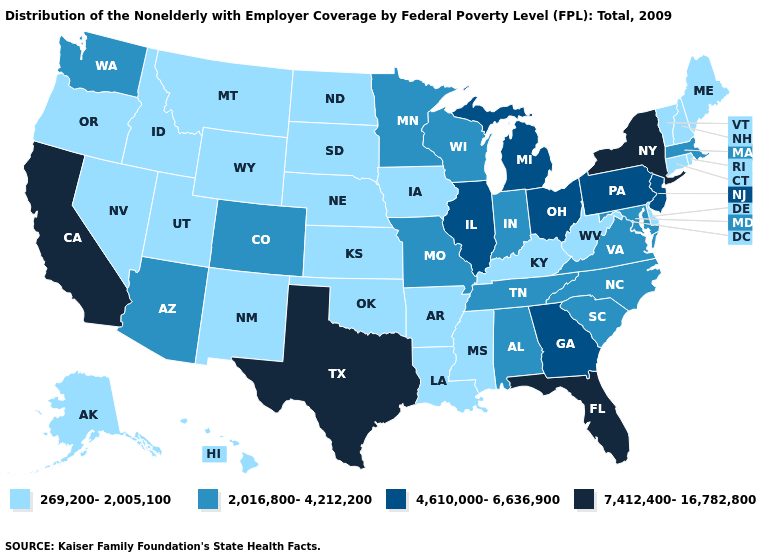What is the value of Arizona?
Write a very short answer. 2,016,800-4,212,200. Name the states that have a value in the range 4,610,000-6,636,900?
Quick response, please. Georgia, Illinois, Michigan, New Jersey, Ohio, Pennsylvania. Among the states that border Nevada , which have the lowest value?
Write a very short answer. Idaho, Oregon, Utah. Name the states that have a value in the range 7,412,400-16,782,800?
Quick response, please. California, Florida, New York, Texas. What is the value of Alaska?
Answer briefly. 269,200-2,005,100. Among the states that border Iowa , which have the highest value?
Keep it brief. Illinois. Among the states that border Kentucky , does Virginia have the highest value?
Keep it brief. No. Is the legend a continuous bar?
Short answer required. No. Among the states that border Louisiana , does Mississippi have the highest value?
Quick response, please. No. Name the states that have a value in the range 2,016,800-4,212,200?
Give a very brief answer. Alabama, Arizona, Colorado, Indiana, Maryland, Massachusetts, Minnesota, Missouri, North Carolina, South Carolina, Tennessee, Virginia, Washington, Wisconsin. What is the lowest value in the West?
Quick response, please. 269,200-2,005,100. Name the states that have a value in the range 7,412,400-16,782,800?
Keep it brief. California, Florida, New York, Texas. Does Arkansas have the same value as Arizona?
Short answer required. No. Does New Mexico have the lowest value in the USA?
Give a very brief answer. Yes. Name the states that have a value in the range 4,610,000-6,636,900?
Give a very brief answer. Georgia, Illinois, Michigan, New Jersey, Ohio, Pennsylvania. 